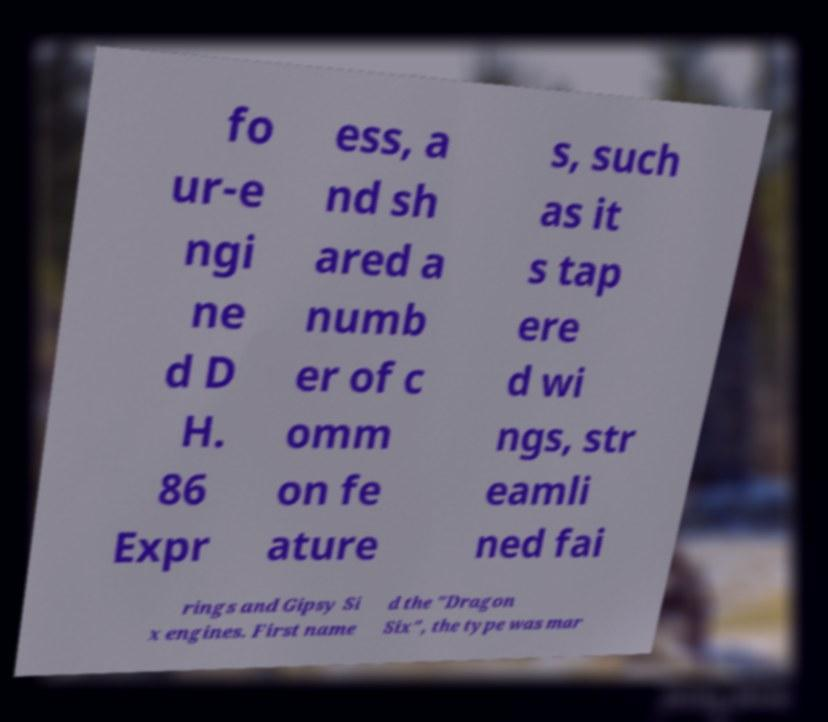Can you read and provide the text displayed in the image?This photo seems to have some interesting text. Can you extract and type it out for me? fo ur-e ngi ne d D H. 86 Expr ess, a nd sh ared a numb er of c omm on fe ature s, such as it s tap ere d wi ngs, str eamli ned fai rings and Gipsy Si x engines. First name d the "Dragon Six", the type was mar 